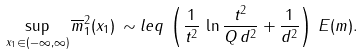Convert formula to latex. <formula><loc_0><loc_0><loc_500><loc_500>\sup _ { x _ { 1 } \in ( - \infty , \infty ) } \overline { m } _ { 1 } ^ { 2 } ( x _ { 1 } ) \, \sim l e q \, \left ( \frac { 1 } { t ^ { 2 } } \, \ln \frac { t ^ { 2 } } { Q \, d ^ { 2 } } + \frac { 1 } { d ^ { 2 } } \right ) \, E ( m ) .</formula> 